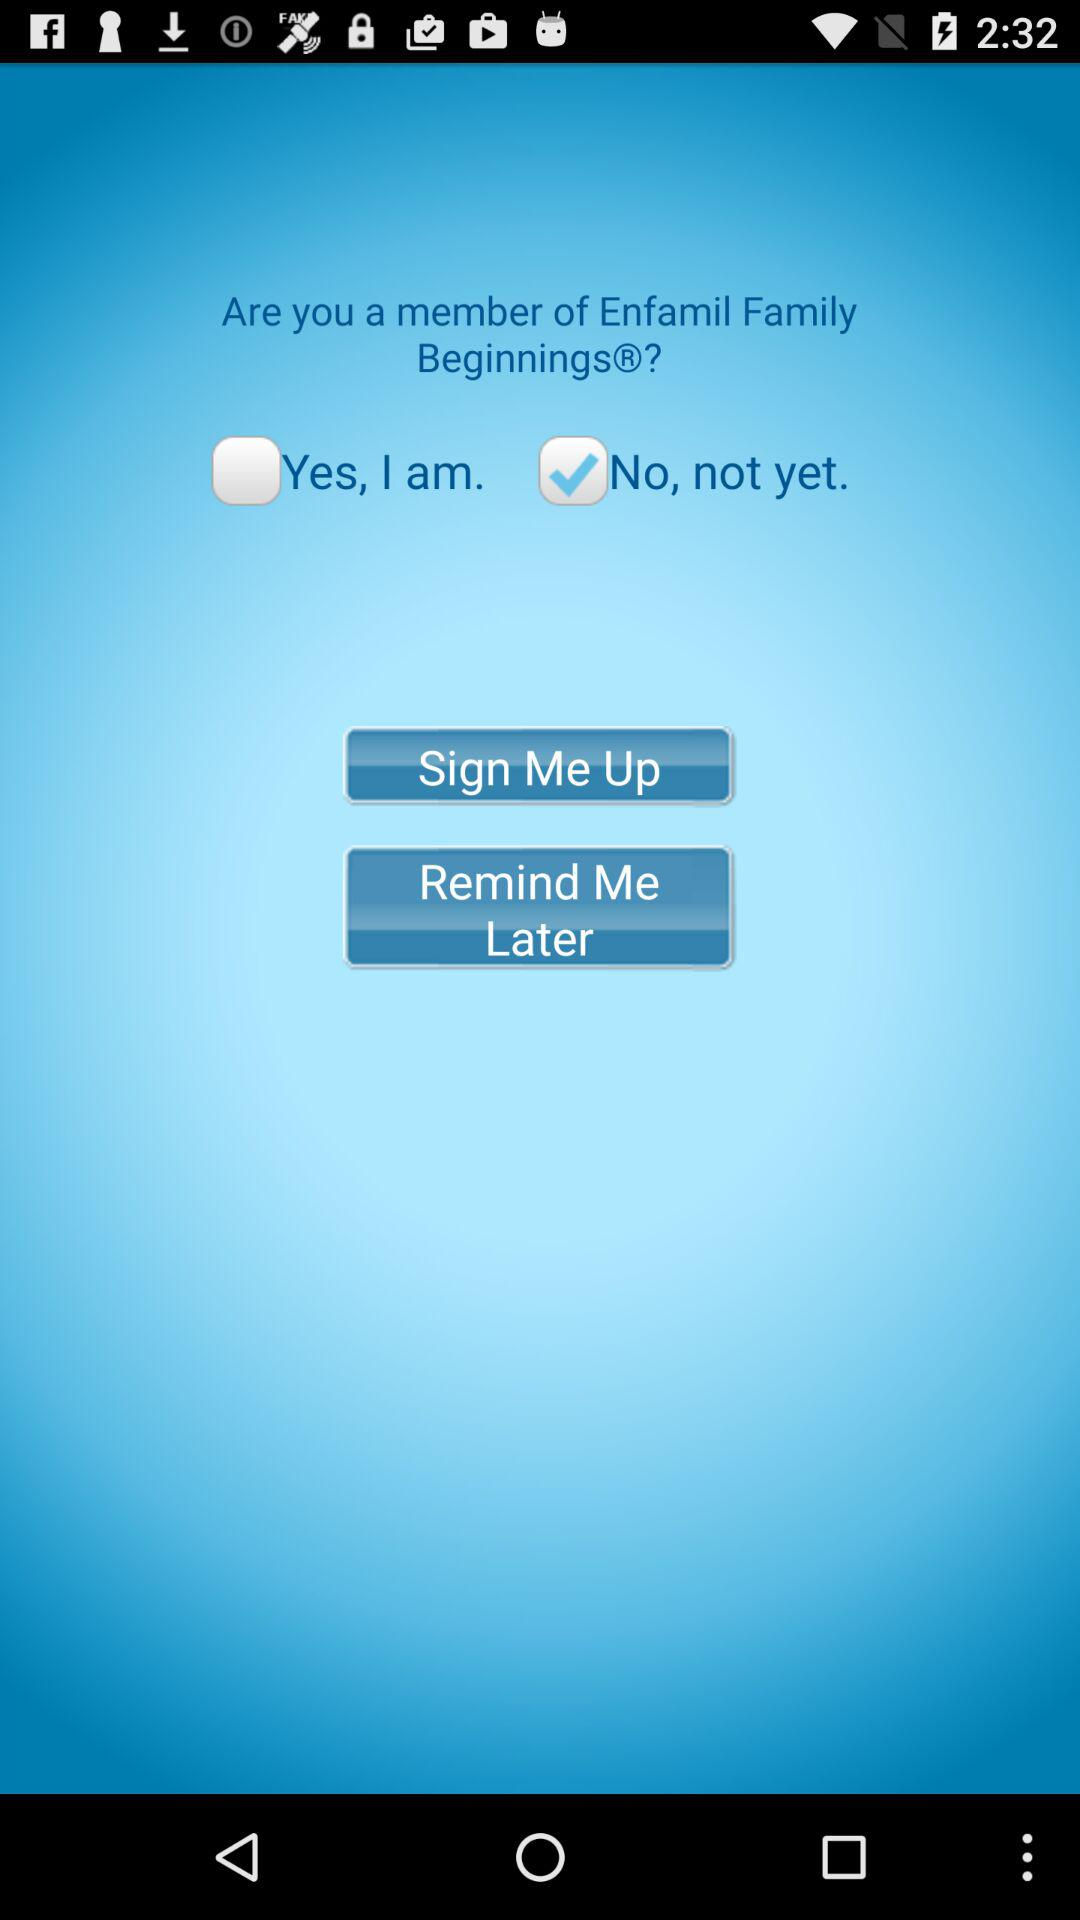Who is this application powered by?
When the provided information is insufficient, respond with <no answer>. <no answer> 